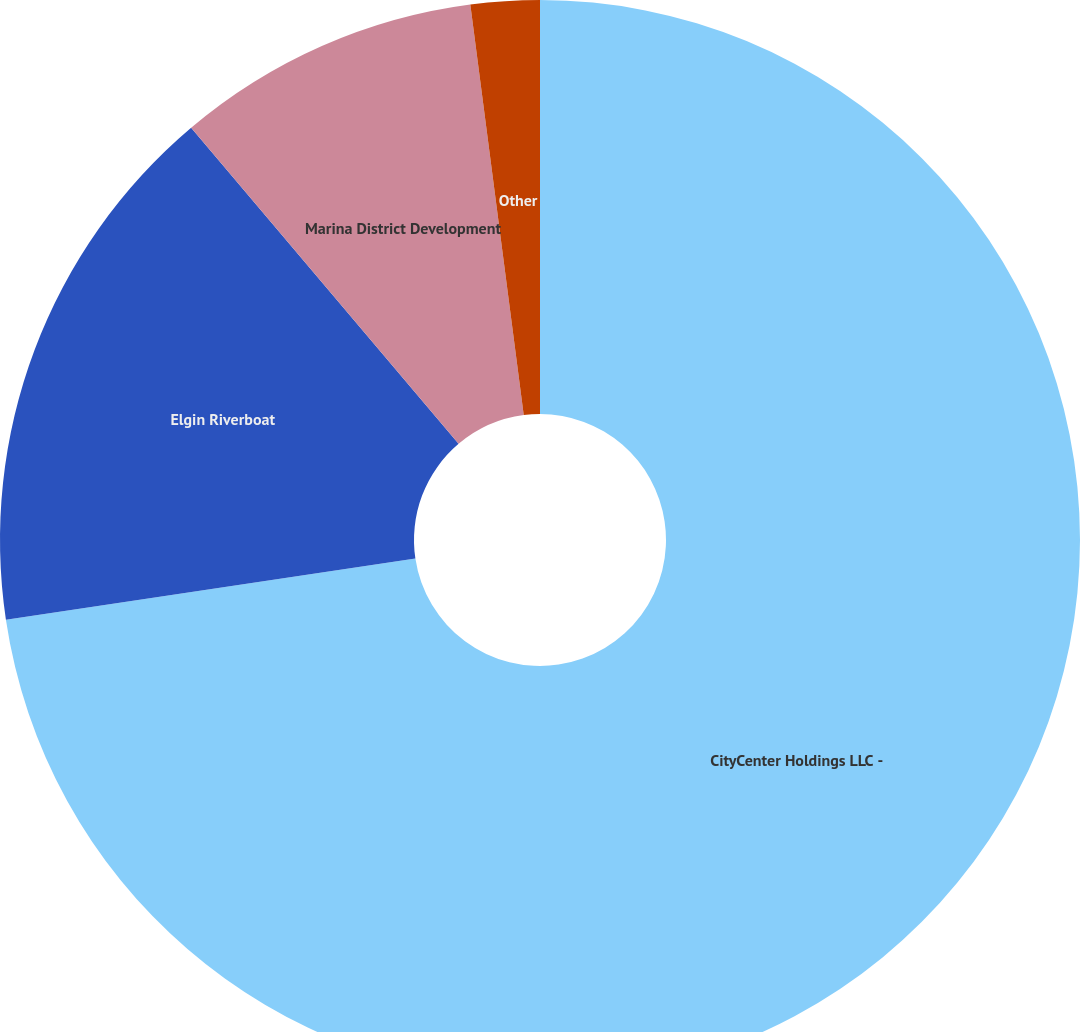Convert chart. <chart><loc_0><loc_0><loc_500><loc_500><pie_chart><fcel>CityCenter Holdings LLC -<fcel>Elgin Riverboat<fcel>Marina District Development<fcel>Other<nl><fcel>72.65%<fcel>16.18%<fcel>9.12%<fcel>2.06%<nl></chart> 